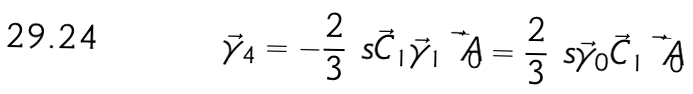Convert formula to latex. <formula><loc_0><loc_0><loc_500><loc_500>\vec { \gamma } _ { 4 } = - \frac { 2 } { 3 } \ s { \vec { C } _ { 1 } } { \vec { \gamma } _ { 1 } } \bar { \vec { A } _ { 0 } } = \frac { 2 } { 3 } \ s { \vec { \gamma } _ { 0 } } { \vec { C } _ { 1 } } \bar { \vec { A } _ { 0 } }</formula> 